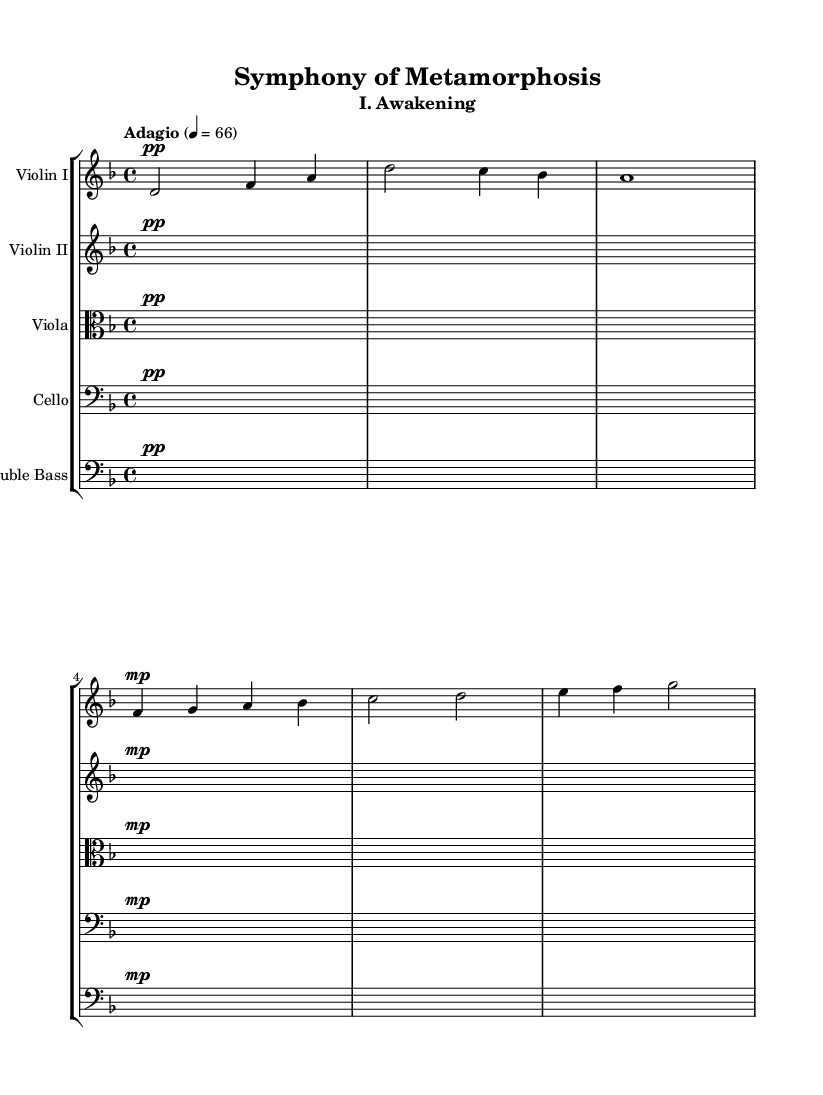What is the key signature of this music? The key signature is indicated at the beginning of the score, showing one flat (B♭). This corresponds to the key of D minor.
Answer: D minor What is the time signature of this music? The time signature, located at the beginning of the score, is 4/4, indicating four beats per measure.
Answer: 4/4 What is the tempo marking in this music? The tempo marking is provided at the beginning, labeled as "Adagio," which indicates a slow tempo.
Answer: Adagio How many measures are in the main theme of this music? Counting the measures in the mainTheme, there are three measures: the first containing the notes D, F, and A, the second containing D, C, and B♭, and the last being held for a whole note.
Answer: 3 measures What dynamics are indicated for Violin I in the music? The dynamics for Violin I are indicated as pianissimo (pp) initially and then changing to mezzo-piano (mp) for the secondary theme. This shows a gradual increase in volume.
Answer: pp, mp What instruments are included in this score? The score includes five instruments: Violin I, Violin II, Viola, Cello, and Double Bass, each indicated by its respective staff label.
Answer: Violin I, Violin II, Viola, Cello, Double Bass What is the title of this piece? The title is explicitly mentioned at the top of the score, which is “Symphony of Metamorphosis.”
Answer: Symphony of Metamorphosis 